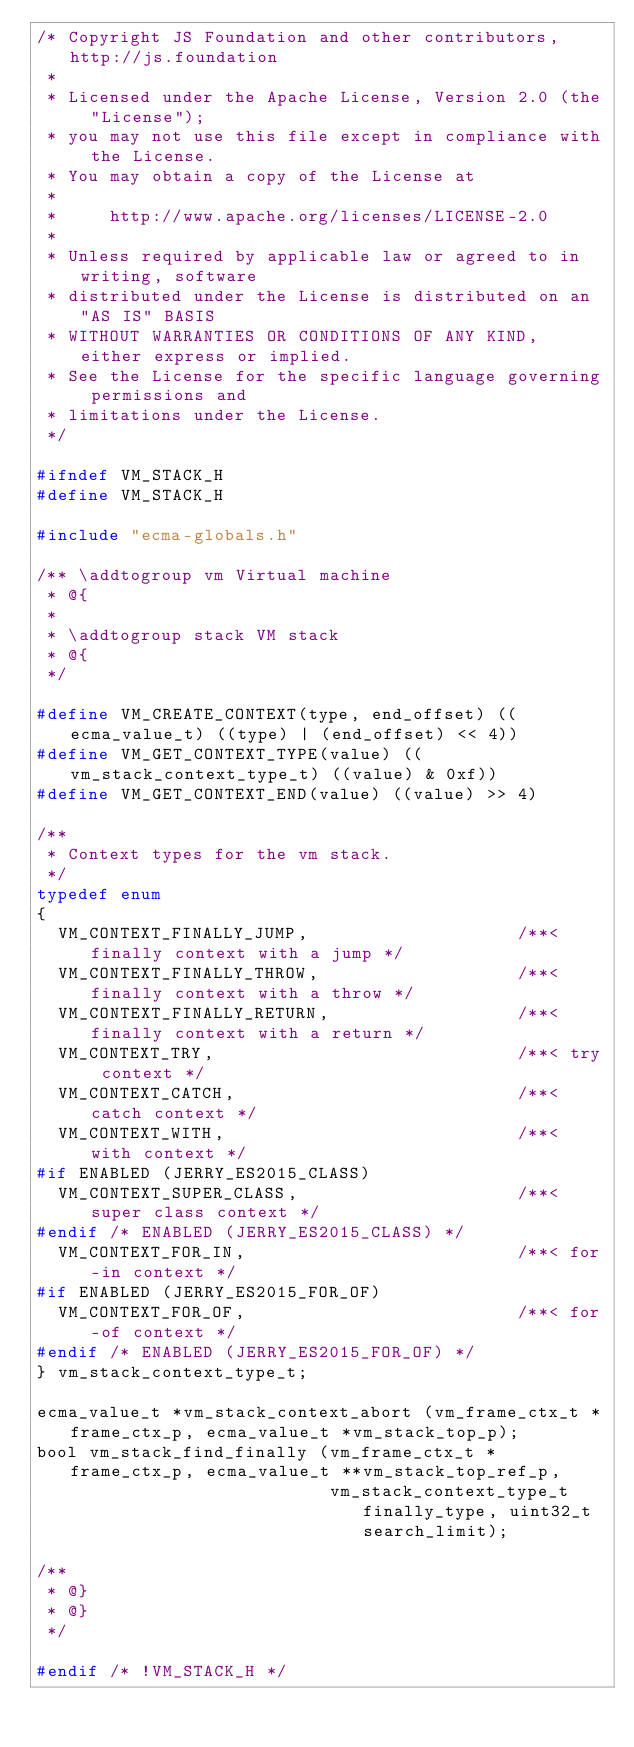Convert code to text. <code><loc_0><loc_0><loc_500><loc_500><_C_>/* Copyright JS Foundation and other contributors, http://js.foundation
 *
 * Licensed under the Apache License, Version 2.0 (the "License");
 * you may not use this file except in compliance with the License.
 * You may obtain a copy of the License at
 *
 *     http://www.apache.org/licenses/LICENSE-2.0
 *
 * Unless required by applicable law or agreed to in writing, software
 * distributed under the License is distributed on an "AS IS" BASIS
 * WITHOUT WARRANTIES OR CONDITIONS OF ANY KIND, either express or implied.
 * See the License for the specific language governing permissions and
 * limitations under the License.
 */

#ifndef VM_STACK_H
#define VM_STACK_H

#include "ecma-globals.h"

/** \addtogroup vm Virtual machine
 * @{
 *
 * \addtogroup stack VM stack
 * @{
 */

#define VM_CREATE_CONTEXT(type, end_offset) ((ecma_value_t) ((type) | (end_offset) << 4))
#define VM_GET_CONTEXT_TYPE(value) ((vm_stack_context_type_t) ((value) & 0xf))
#define VM_GET_CONTEXT_END(value) ((value) >> 4)

/**
 * Context types for the vm stack.
 */
typedef enum
{
  VM_CONTEXT_FINALLY_JUMP,                    /**< finally context with a jump */
  VM_CONTEXT_FINALLY_THROW,                   /**< finally context with a throw */
  VM_CONTEXT_FINALLY_RETURN,                  /**< finally context with a return */
  VM_CONTEXT_TRY,                             /**< try context */
  VM_CONTEXT_CATCH,                           /**< catch context */
  VM_CONTEXT_WITH,                            /**< with context */
#if ENABLED (JERRY_ES2015_CLASS)
  VM_CONTEXT_SUPER_CLASS,                     /**< super class context */
#endif /* ENABLED (JERRY_ES2015_CLASS) */
  VM_CONTEXT_FOR_IN,                          /**< for-in context */
#if ENABLED (JERRY_ES2015_FOR_OF)
  VM_CONTEXT_FOR_OF,                          /**< for-of context */
#endif /* ENABLED (JERRY_ES2015_FOR_OF) */
} vm_stack_context_type_t;

ecma_value_t *vm_stack_context_abort (vm_frame_ctx_t *frame_ctx_p, ecma_value_t *vm_stack_top_p);
bool vm_stack_find_finally (vm_frame_ctx_t *frame_ctx_p, ecma_value_t **vm_stack_top_ref_p,
                            vm_stack_context_type_t finally_type, uint32_t search_limit);

/**
 * @}
 * @}
 */

#endif /* !VM_STACK_H */
</code> 